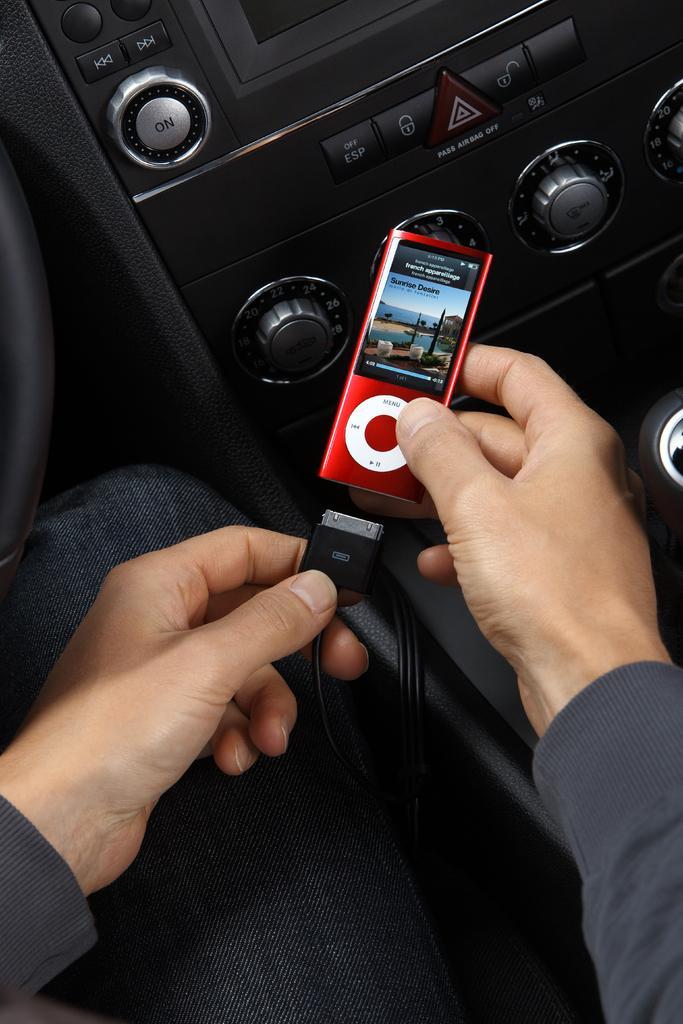How would you summarize this image in a sentence or two? In this image I can see the person is holding the ipod and I can see the music system of the vehicle. 